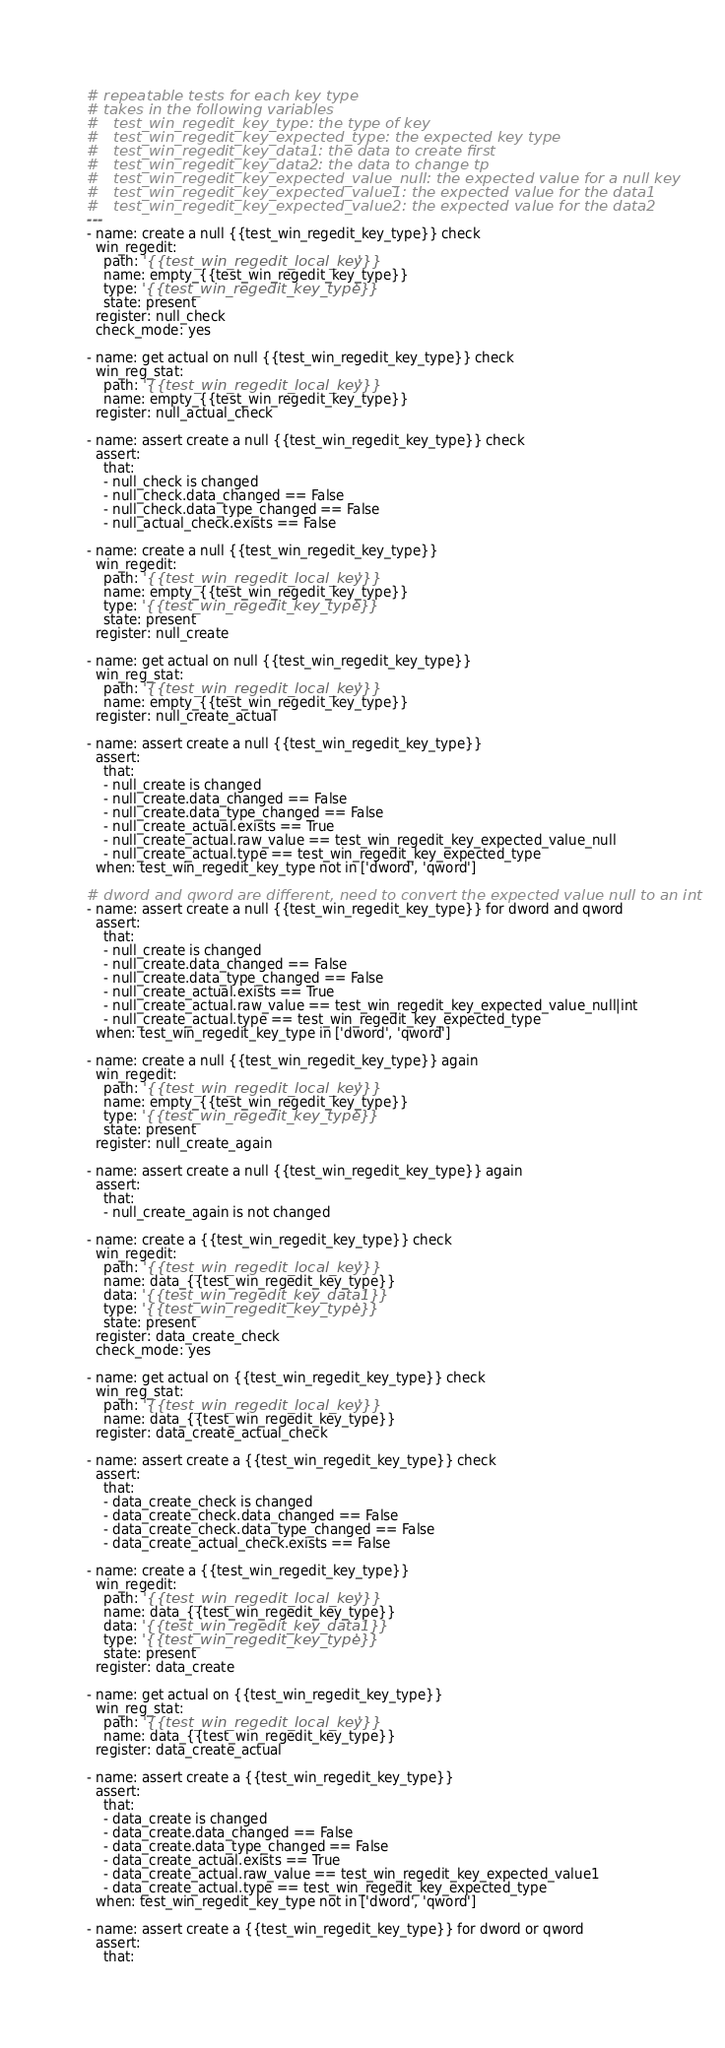Convert code to text. <code><loc_0><loc_0><loc_500><loc_500><_YAML_># repeatable tests for each key type
# takes in the following variables
#   test_win_regedit_key_type: the type of key
#   test_win_regedit_key_expected_type: the expected key type
#   test_win_regedit_key_data1: the data to create first
#   test_win_regedit_key_data2: the data to change tp
#   test_win_regedit_key_expected_value_null: the expected value for a null key
#   test_win_regedit_key_expected_value1: the expected value for the data1
#   test_win_regedit_key_expected_value2: the expected value for the data2
---
- name: create a null {{test_win_regedit_key_type}} check
  win_regedit:
    path: '{{test_win_regedit_local_key}}'
    name: empty_{{test_win_regedit_key_type}}
    type: '{{test_win_regedit_key_type}}'
    state: present
  register: null_check
  check_mode: yes

- name: get actual on null {{test_win_regedit_key_type}} check
  win_reg_stat:
    path: '{{test_win_regedit_local_key}}'
    name: empty_{{test_win_regedit_key_type}}
  register: null_actual_check

- name: assert create a null {{test_win_regedit_key_type}} check
  assert:
    that:
    - null_check is changed
    - null_check.data_changed == False
    - null_check.data_type_changed == False
    - null_actual_check.exists == False

- name: create a null {{test_win_regedit_key_type}}
  win_regedit:
    path: '{{test_win_regedit_local_key}}'
    name: empty_{{test_win_regedit_key_type}}
    type: '{{test_win_regedit_key_type}}'
    state: present
  register: null_create

- name: get actual on null {{test_win_regedit_key_type}}
  win_reg_stat:
    path: '{{test_win_regedit_local_key}}'
    name: empty_{{test_win_regedit_key_type}}
  register: null_create_actual

- name: assert create a null {{test_win_regedit_key_type}}
  assert:
    that:
    - null_create is changed
    - null_create.data_changed == False
    - null_create.data_type_changed == False
    - null_create_actual.exists == True
    - null_create_actual.raw_value == test_win_regedit_key_expected_value_null
    - null_create_actual.type == test_win_regedit_key_expected_type
  when: test_win_regedit_key_type not in ['dword', 'qword']

# dword and qword are different, need to convert the expected value null to an int
- name: assert create a null {{test_win_regedit_key_type}} for dword and qword
  assert:
    that:
    - null_create is changed
    - null_create.data_changed == False
    - null_create.data_type_changed == False
    - null_create_actual.exists == True
    - null_create_actual.raw_value == test_win_regedit_key_expected_value_null|int
    - null_create_actual.type == test_win_regedit_key_expected_type
  when: test_win_regedit_key_type in ['dword', 'qword']

- name: create a null {{test_win_regedit_key_type}} again
  win_regedit:
    path: '{{test_win_regedit_local_key}}'
    name: empty_{{test_win_regedit_key_type}}
    type: '{{test_win_regedit_key_type}}'
    state: present
  register: null_create_again

- name: assert create a null {{test_win_regedit_key_type}} again
  assert:
    that:
    - null_create_again is not changed

- name: create a {{test_win_regedit_key_type}} check
  win_regedit:
    path: '{{test_win_regedit_local_key}}'
    name: data_{{test_win_regedit_key_type}}
    data: '{{test_win_regedit_key_data1}}'
    type: '{{test_win_regedit_key_type}}'
    state: present
  register: data_create_check
  check_mode: yes

- name: get actual on {{test_win_regedit_key_type}} check
  win_reg_stat:
    path: '{{test_win_regedit_local_key}}'
    name: data_{{test_win_regedit_key_type}}
  register: data_create_actual_check

- name: assert create a {{test_win_regedit_key_type}} check
  assert:
    that:
    - data_create_check is changed
    - data_create_check.data_changed == False
    - data_create_check.data_type_changed == False
    - data_create_actual_check.exists == False

- name: create a {{test_win_regedit_key_type}}
  win_regedit:
    path: '{{test_win_regedit_local_key}}'
    name: data_{{test_win_regedit_key_type}}
    data: '{{test_win_regedit_key_data1}}'
    type: '{{test_win_regedit_key_type}}'
    state: present
  register: data_create

- name: get actual on {{test_win_regedit_key_type}}
  win_reg_stat:
    path: '{{test_win_regedit_local_key}}'
    name: data_{{test_win_regedit_key_type}}
  register: data_create_actual

- name: assert create a {{test_win_regedit_key_type}}
  assert:
    that:
    - data_create is changed
    - data_create.data_changed == False
    - data_create.data_type_changed == False
    - data_create_actual.exists == True
    - data_create_actual.raw_value == test_win_regedit_key_expected_value1
    - data_create_actual.type == test_win_regedit_key_expected_type
  when: test_win_regedit_key_type not in ['dword', 'qword']

- name: assert create a {{test_win_regedit_key_type}} for dword or qword
  assert:
    that:</code> 